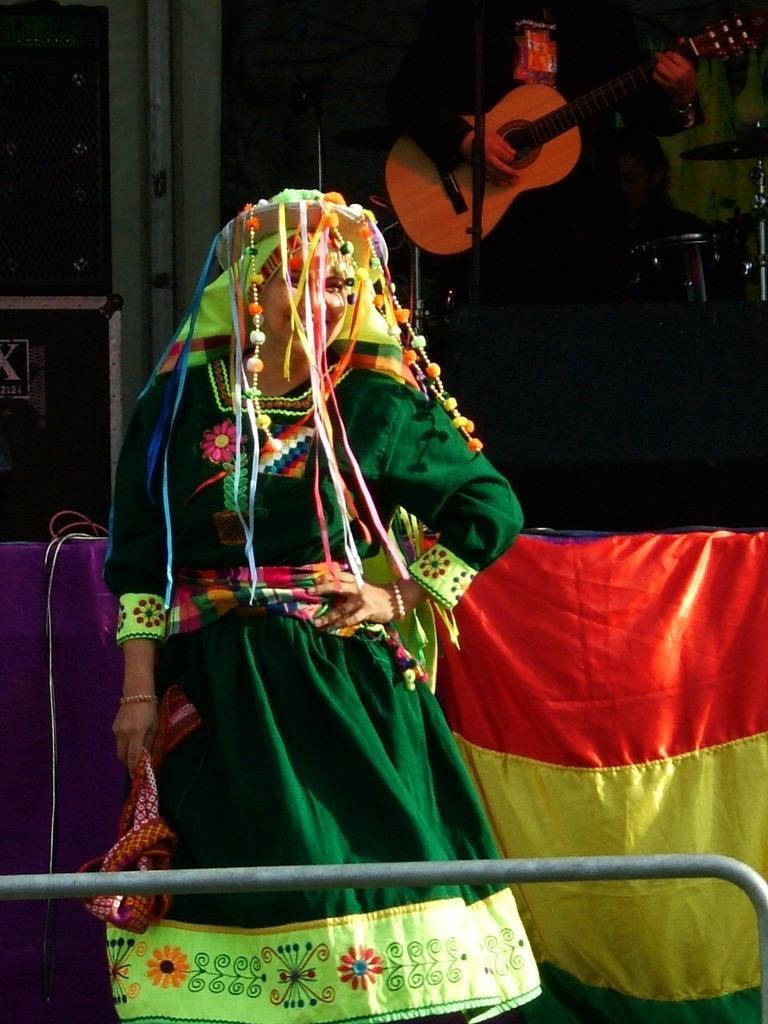Describe this image in one or two sentences. In this image, In the middle there is a woman she is standing and she is wearing a green color shirt, In the background there is a red and yellow color cloth, There is a man standing and he is holding a music instrument which is in yellow color. 